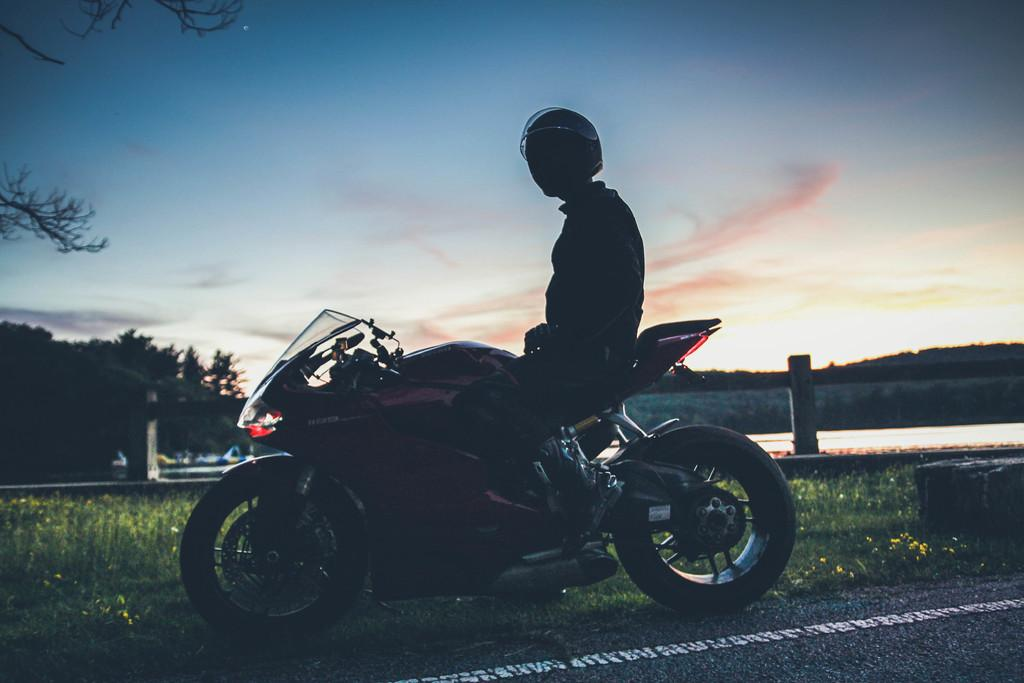Who is present in the image? There is a man in the image. What is the man with in the image? The man is with a motorcycle. What can be seen in the background of the image? There are trees around the man and motorcycle. How would you describe the weather based on the image? The sky is cloudy in the image. What type of instrument is the man playing in the image? There is no instrument present in the image; the man is with a motorcycle. 